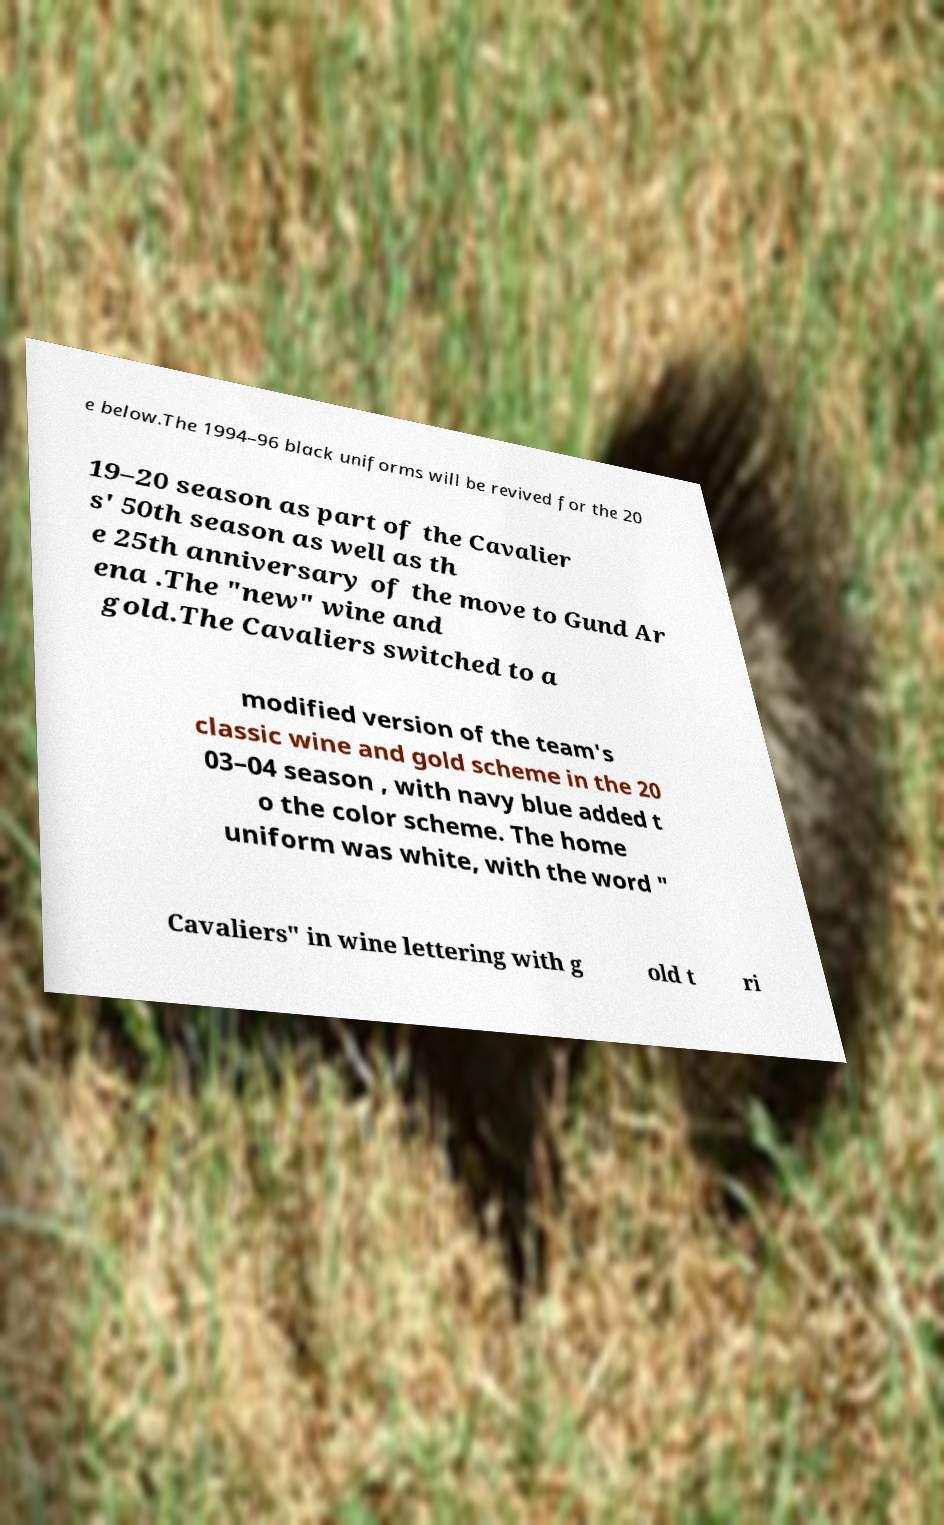Please identify and transcribe the text found in this image. e below.The 1994–96 black uniforms will be revived for the 20 19–20 season as part of the Cavalier s' 50th season as well as th e 25th anniversary of the move to Gund Ar ena .The "new" wine and gold.The Cavaliers switched to a modified version of the team's classic wine and gold scheme in the 20 03–04 season , with navy blue added t o the color scheme. The home uniform was white, with the word " Cavaliers" in wine lettering with g old t ri 